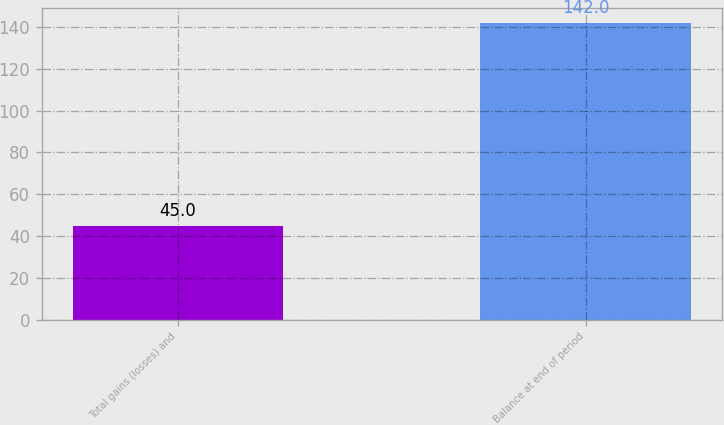<chart> <loc_0><loc_0><loc_500><loc_500><bar_chart><fcel>Total gains (losses) and<fcel>Balance at end of period<nl><fcel>45<fcel>142<nl></chart> 